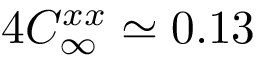Convert formula to latex. <formula><loc_0><loc_0><loc_500><loc_500>4 C _ { \infty } ^ { x x } \simeq 0 . 1 3</formula> 